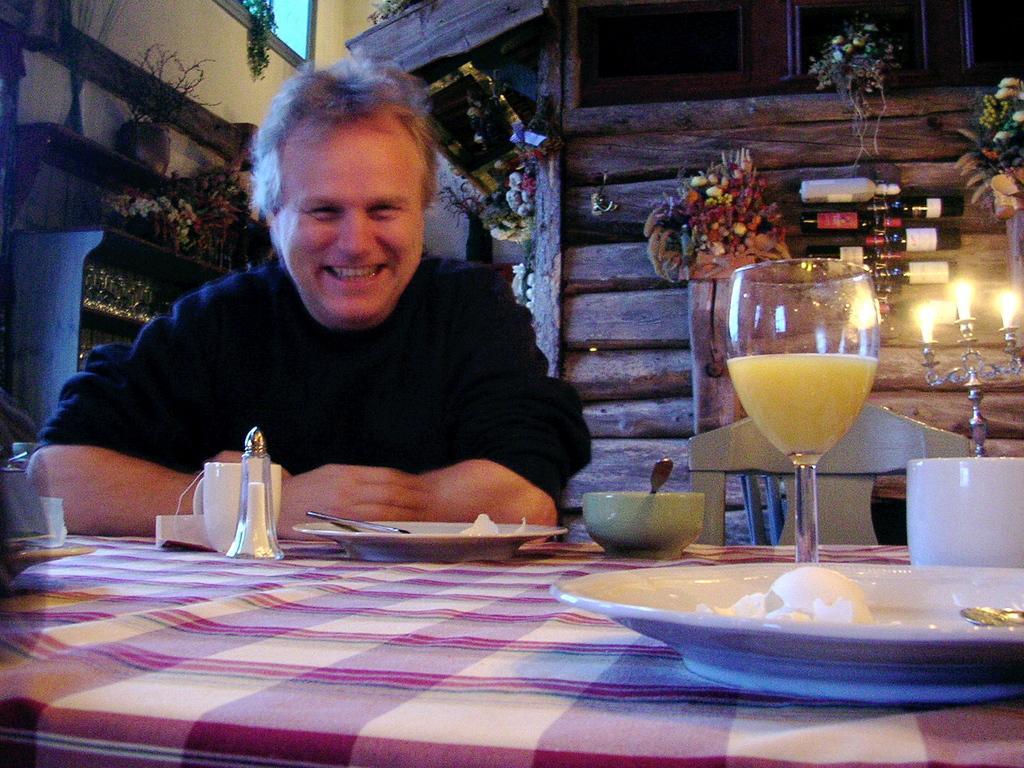How would you summarize this image in a sentence or two? This picture is clicked inside a room and in middle we see man in black t-shirt is sitting on a chair and laughing. In front of him, we see a table with white and pink cloth covered on it. On the table, we can see plate, bowl, spoon, cup, glass and behind him, we see a wall with many flower pots and decorative items and on top of him, we see a window. 